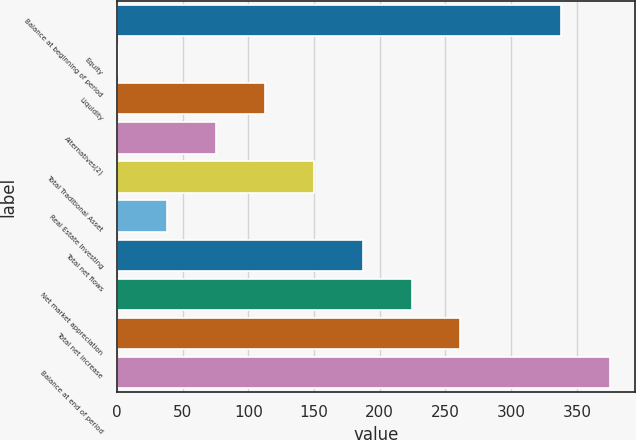<chart> <loc_0><loc_0><loc_500><loc_500><bar_chart><fcel>Balance at beginning of period<fcel>Equity<fcel>Liquidity<fcel>Alternatives(2)<fcel>Total Traditional Asset<fcel>Real Estate Investing<fcel>Total net flows<fcel>Net market appreciation<fcel>Total net increase<fcel>Balance at end of period<nl><fcel>338<fcel>1<fcel>112.6<fcel>75.4<fcel>149.8<fcel>38.2<fcel>187<fcel>224.2<fcel>261.4<fcel>375.2<nl></chart> 